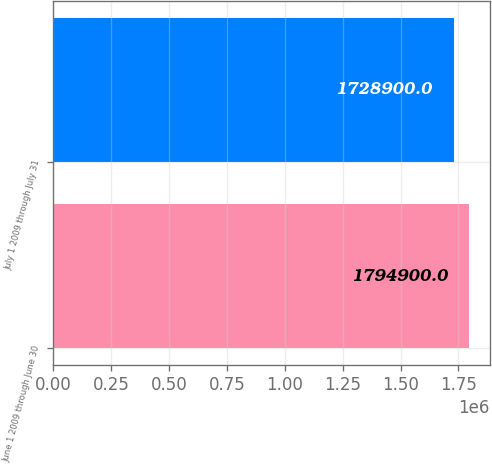Convert chart to OTSL. <chart><loc_0><loc_0><loc_500><loc_500><bar_chart><fcel>June 1 2009 through June 30<fcel>July 1 2009 through July 31<nl><fcel>1.7949e+06<fcel>1.7289e+06<nl></chart> 